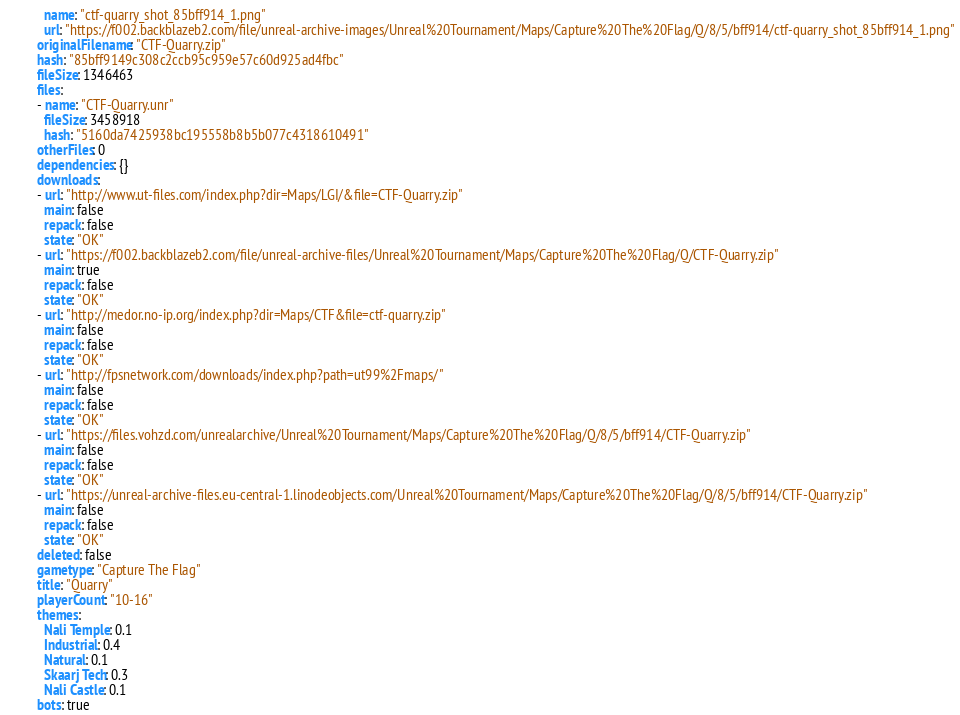<code> <loc_0><loc_0><loc_500><loc_500><_YAML_>  name: "ctf-quarry_shot_85bff914_1.png"
  url: "https://f002.backblazeb2.com/file/unreal-archive-images/Unreal%20Tournament/Maps/Capture%20The%20Flag/Q/8/5/bff914/ctf-quarry_shot_85bff914_1.png"
originalFilename: "CTF-Quarry.zip"
hash: "85bff9149c308c2ccb95c959e57c60d925ad4fbc"
fileSize: 1346463
files:
- name: "CTF-Quarry.unr"
  fileSize: 3458918
  hash: "5160da7425938bc195558b8b5b077c4318610491"
otherFiles: 0
dependencies: {}
downloads:
- url: "http://www.ut-files.com/index.php?dir=Maps/LGI/&file=CTF-Quarry.zip"
  main: false
  repack: false
  state: "OK"
- url: "https://f002.backblazeb2.com/file/unreal-archive-files/Unreal%20Tournament/Maps/Capture%20The%20Flag/Q/CTF-Quarry.zip"
  main: true
  repack: false
  state: "OK"
- url: "http://medor.no-ip.org/index.php?dir=Maps/CTF&file=ctf-quarry.zip"
  main: false
  repack: false
  state: "OK"
- url: "http://fpsnetwork.com/downloads/index.php?path=ut99%2Fmaps/"
  main: false
  repack: false
  state: "OK"
- url: "https://files.vohzd.com/unrealarchive/Unreal%20Tournament/Maps/Capture%20The%20Flag/Q/8/5/bff914/CTF-Quarry.zip"
  main: false
  repack: false
  state: "OK"
- url: "https://unreal-archive-files.eu-central-1.linodeobjects.com/Unreal%20Tournament/Maps/Capture%20The%20Flag/Q/8/5/bff914/CTF-Quarry.zip"
  main: false
  repack: false
  state: "OK"
deleted: false
gametype: "Capture The Flag"
title: "Quarry"
playerCount: "10-16"
themes:
  Nali Temple: 0.1
  Industrial: 0.4
  Natural: 0.1
  Skaarj Tech: 0.3
  Nali Castle: 0.1
bots: true
</code> 